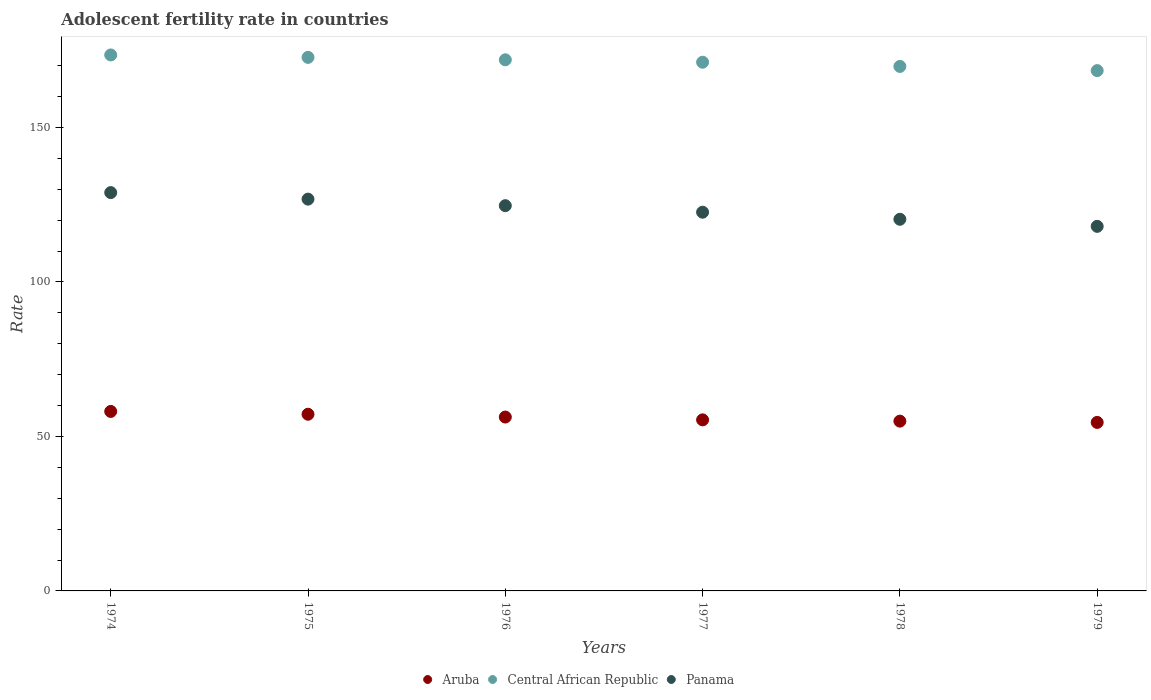What is the adolescent fertility rate in Central African Republic in 1974?
Your answer should be compact. 173.48. Across all years, what is the maximum adolescent fertility rate in Central African Republic?
Your answer should be compact. 173.48. Across all years, what is the minimum adolescent fertility rate in Aruba?
Offer a terse response. 54.54. In which year was the adolescent fertility rate in Central African Republic maximum?
Offer a very short reply. 1974. In which year was the adolescent fertility rate in Aruba minimum?
Give a very brief answer. 1979. What is the total adolescent fertility rate in Central African Republic in the graph?
Ensure brevity in your answer.  1027.37. What is the difference between the adolescent fertility rate in Aruba in 1974 and that in 1975?
Give a very brief answer. 0.91. What is the difference between the adolescent fertility rate in Aruba in 1977 and the adolescent fertility rate in Central African Republic in 1974?
Ensure brevity in your answer.  -118.11. What is the average adolescent fertility rate in Aruba per year?
Give a very brief answer. 56.07. In the year 1977, what is the difference between the adolescent fertility rate in Central African Republic and adolescent fertility rate in Panama?
Your response must be concise. 48.55. In how many years, is the adolescent fertility rate in Aruba greater than 60?
Offer a very short reply. 0. What is the ratio of the adolescent fertility rate in Aruba in 1976 to that in 1978?
Keep it short and to the point. 1.02. Is the difference between the adolescent fertility rate in Central African Republic in 1975 and 1977 greater than the difference between the adolescent fertility rate in Panama in 1975 and 1977?
Provide a succinct answer. No. What is the difference between the highest and the second highest adolescent fertility rate in Panama?
Provide a short and direct response. 2.12. What is the difference between the highest and the lowest adolescent fertility rate in Central African Republic?
Provide a succinct answer. 5.07. In how many years, is the adolescent fertility rate in Panama greater than the average adolescent fertility rate in Panama taken over all years?
Offer a very short reply. 3. Does the adolescent fertility rate in Panama monotonically increase over the years?
Give a very brief answer. No. How many dotlines are there?
Give a very brief answer. 3. How many years are there in the graph?
Provide a short and direct response. 6. What is the difference between two consecutive major ticks on the Y-axis?
Ensure brevity in your answer.  50. Does the graph contain any zero values?
Keep it short and to the point. No. Does the graph contain grids?
Your response must be concise. No. How many legend labels are there?
Your response must be concise. 3. What is the title of the graph?
Offer a terse response. Adolescent fertility rate in countries. Does "Denmark" appear as one of the legend labels in the graph?
Your answer should be very brief. No. What is the label or title of the Y-axis?
Your answer should be compact. Rate. What is the Rate in Aruba in 1974?
Offer a terse response. 58.1. What is the Rate in Central African Republic in 1974?
Give a very brief answer. 173.48. What is the Rate in Panama in 1974?
Provide a short and direct response. 128.93. What is the Rate in Aruba in 1975?
Offer a very short reply. 57.19. What is the Rate of Central African Republic in 1975?
Your answer should be very brief. 172.69. What is the Rate of Panama in 1975?
Offer a very short reply. 126.81. What is the Rate in Aruba in 1976?
Your response must be concise. 56.28. What is the Rate in Central African Republic in 1976?
Keep it short and to the point. 171.91. What is the Rate of Panama in 1976?
Offer a very short reply. 124.69. What is the Rate of Aruba in 1977?
Give a very brief answer. 55.37. What is the Rate in Central African Republic in 1977?
Give a very brief answer. 171.12. What is the Rate of Panama in 1977?
Make the answer very short. 122.58. What is the Rate of Aruba in 1978?
Your answer should be very brief. 54.95. What is the Rate of Central African Republic in 1978?
Ensure brevity in your answer.  169.77. What is the Rate of Panama in 1978?
Provide a succinct answer. 120.29. What is the Rate in Aruba in 1979?
Offer a terse response. 54.54. What is the Rate in Central African Republic in 1979?
Make the answer very short. 168.41. What is the Rate of Panama in 1979?
Offer a very short reply. 118. Across all years, what is the maximum Rate in Aruba?
Offer a terse response. 58.1. Across all years, what is the maximum Rate of Central African Republic?
Keep it short and to the point. 173.48. Across all years, what is the maximum Rate of Panama?
Provide a short and direct response. 128.93. Across all years, what is the minimum Rate of Aruba?
Provide a succinct answer. 54.54. Across all years, what is the minimum Rate of Central African Republic?
Your answer should be very brief. 168.41. Across all years, what is the minimum Rate of Panama?
Your response must be concise. 118. What is the total Rate in Aruba in the graph?
Offer a terse response. 336.42. What is the total Rate in Central African Republic in the graph?
Provide a succinct answer. 1027.37. What is the total Rate of Panama in the graph?
Your response must be concise. 741.3. What is the difference between the Rate in Aruba in 1974 and that in 1975?
Offer a terse response. 0.91. What is the difference between the Rate in Central African Republic in 1974 and that in 1975?
Offer a terse response. 0.79. What is the difference between the Rate of Panama in 1974 and that in 1975?
Provide a short and direct response. 2.12. What is the difference between the Rate in Aruba in 1974 and that in 1976?
Provide a short and direct response. 1.82. What is the difference between the Rate in Central African Republic in 1974 and that in 1976?
Make the answer very short. 1.57. What is the difference between the Rate of Panama in 1974 and that in 1976?
Offer a terse response. 4.23. What is the difference between the Rate of Aruba in 1974 and that in 1977?
Ensure brevity in your answer.  2.73. What is the difference between the Rate of Central African Republic in 1974 and that in 1977?
Keep it short and to the point. 2.36. What is the difference between the Rate in Panama in 1974 and that in 1977?
Make the answer very short. 6.35. What is the difference between the Rate of Aruba in 1974 and that in 1978?
Keep it short and to the point. 3.14. What is the difference between the Rate of Central African Republic in 1974 and that in 1978?
Keep it short and to the point. 3.71. What is the difference between the Rate in Panama in 1974 and that in 1978?
Offer a terse response. 8.64. What is the difference between the Rate of Aruba in 1974 and that in 1979?
Your answer should be compact. 3.56. What is the difference between the Rate in Central African Republic in 1974 and that in 1979?
Offer a terse response. 5.07. What is the difference between the Rate in Panama in 1974 and that in 1979?
Provide a succinct answer. 10.92. What is the difference between the Rate in Aruba in 1975 and that in 1976?
Your response must be concise. 0.91. What is the difference between the Rate in Central African Republic in 1975 and that in 1976?
Make the answer very short. 0.79. What is the difference between the Rate of Panama in 1975 and that in 1976?
Offer a very short reply. 2.12. What is the difference between the Rate in Aruba in 1975 and that in 1977?
Make the answer very short. 1.82. What is the difference between the Rate in Central African Republic in 1975 and that in 1977?
Give a very brief answer. 1.57. What is the difference between the Rate in Panama in 1975 and that in 1977?
Your answer should be compact. 4.23. What is the difference between the Rate of Aruba in 1975 and that in 1978?
Ensure brevity in your answer.  2.23. What is the difference between the Rate of Central African Republic in 1975 and that in 1978?
Offer a very short reply. 2.93. What is the difference between the Rate of Panama in 1975 and that in 1978?
Keep it short and to the point. 6.52. What is the difference between the Rate of Aruba in 1975 and that in 1979?
Offer a terse response. 2.65. What is the difference between the Rate of Central African Republic in 1975 and that in 1979?
Make the answer very short. 4.28. What is the difference between the Rate of Panama in 1975 and that in 1979?
Provide a short and direct response. 8.81. What is the difference between the Rate of Aruba in 1976 and that in 1977?
Your answer should be compact. 0.91. What is the difference between the Rate of Central African Republic in 1976 and that in 1977?
Make the answer very short. 0.79. What is the difference between the Rate of Panama in 1976 and that in 1977?
Keep it short and to the point. 2.12. What is the difference between the Rate in Aruba in 1976 and that in 1978?
Offer a very short reply. 1.32. What is the difference between the Rate of Central African Republic in 1976 and that in 1978?
Offer a very short reply. 2.14. What is the difference between the Rate in Panama in 1976 and that in 1978?
Provide a succinct answer. 4.4. What is the difference between the Rate in Aruba in 1976 and that in 1979?
Provide a succinct answer. 1.74. What is the difference between the Rate in Central African Republic in 1976 and that in 1979?
Offer a very short reply. 3.5. What is the difference between the Rate of Panama in 1976 and that in 1979?
Your answer should be compact. 6.69. What is the difference between the Rate in Aruba in 1977 and that in 1978?
Make the answer very short. 0.42. What is the difference between the Rate of Central African Republic in 1977 and that in 1978?
Your answer should be very brief. 1.36. What is the difference between the Rate in Panama in 1977 and that in 1978?
Make the answer very short. 2.29. What is the difference between the Rate of Aruba in 1977 and that in 1979?
Offer a very short reply. 0.83. What is the difference between the Rate in Central African Republic in 1977 and that in 1979?
Keep it short and to the point. 2.71. What is the difference between the Rate of Panama in 1977 and that in 1979?
Give a very brief answer. 4.58. What is the difference between the Rate in Aruba in 1978 and that in 1979?
Give a very brief answer. 0.42. What is the difference between the Rate in Central African Republic in 1978 and that in 1979?
Make the answer very short. 1.36. What is the difference between the Rate in Panama in 1978 and that in 1979?
Give a very brief answer. 2.29. What is the difference between the Rate of Aruba in 1974 and the Rate of Central African Republic in 1975?
Provide a succinct answer. -114.6. What is the difference between the Rate in Aruba in 1974 and the Rate in Panama in 1975?
Your answer should be very brief. -68.71. What is the difference between the Rate in Central African Republic in 1974 and the Rate in Panama in 1975?
Your answer should be compact. 46.67. What is the difference between the Rate in Aruba in 1974 and the Rate in Central African Republic in 1976?
Provide a succinct answer. -113.81. What is the difference between the Rate in Aruba in 1974 and the Rate in Panama in 1976?
Offer a very short reply. -66.6. What is the difference between the Rate in Central African Republic in 1974 and the Rate in Panama in 1976?
Provide a succinct answer. 48.78. What is the difference between the Rate of Aruba in 1974 and the Rate of Central African Republic in 1977?
Offer a very short reply. -113.03. What is the difference between the Rate of Aruba in 1974 and the Rate of Panama in 1977?
Your response must be concise. -64.48. What is the difference between the Rate of Central African Republic in 1974 and the Rate of Panama in 1977?
Your answer should be very brief. 50.9. What is the difference between the Rate of Aruba in 1974 and the Rate of Central African Republic in 1978?
Make the answer very short. -111.67. What is the difference between the Rate in Aruba in 1974 and the Rate in Panama in 1978?
Make the answer very short. -62.19. What is the difference between the Rate of Central African Republic in 1974 and the Rate of Panama in 1978?
Ensure brevity in your answer.  53.19. What is the difference between the Rate of Aruba in 1974 and the Rate of Central African Republic in 1979?
Your answer should be compact. -110.31. What is the difference between the Rate of Aruba in 1974 and the Rate of Panama in 1979?
Your response must be concise. -59.91. What is the difference between the Rate in Central African Republic in 1974 and the Rate in Panama in 1979?
Provide a short and direct response. 55.48. What is the difference between the Rate in Aruba in 1975 and the Rate in Central African Republic in 1976?
Give a very brief answer. -114.72. What is the difference between the Rate of Aruba in 1975 and the Rate of Panama in 1976?
Your response must be concise. -67.51. What is the difference between the Rate of Central African Republic in 1975 and the Rate of Panama in 1976?
Your answer should be very brief. 48. What is the difference between the Rate of Aruba in 1975 and the Rate of Central African Republic in 1977?
Keep it short and to the point. -113.93. What is the difference between the Rate in Aruba in 1975 and the Rate in Panama in 1977?
Your response must be concise. -65.39. What is the difference between the Rate in Central African Republic in 1975 and the Rate in Panama in 1977?
Your response must be concise. 50.12. What is the difference between the Rate of Aruba in 1975 and the Rate of Central African Republic in 1978?
Your answer should be compact. -112.58. What is the difference between the Rate in Aruba in 1975 and the Rate in Panama in 1978?
Offer a terse response. -63.1. What is the difference between the Rate in Central African Republic in 1975 and the Rate in Panama in 1978?
Keep it short and to the point. 52.4. What is the difference between the Rate of Aruba in 1975 and the Rate of Central African Republic in 1979?
Provide a short and direct response. -111.22. What is the difference between the Rate of Aruba in 1975 and the Rate of Panama in 1979?
Offer a very short reply. -60.81. What is the difference between the Rate of Central African Republic in 1975 and the Rate of Panama in 1979?
Keep it short and to the point. 54.69. What is the difference between the Rate in Aruba in 1976 and the Rate in Central African Republic in 1977?
Your answer should be compact. -114.84. What is the difference between the Rate of Aruba in 1976 and the Rate of Panama in 1977?
Your response must be concise. -66.3. What is the difference between the Rate of Central African Republic in 1976 and the Rate of Panama in 1977?
Make the answer very short. 49.33. What is the difference between the Rate of Aruba in 1976 and the Rate of Central African Republic in 1978?
Offer a terse response. -113.49. What is the difference between the Rate of Aruba in 1976 and the Rate of Panama in 1978?
Offer a terse response. -64.01. What is the difference between the Rate in Central African Republic in 1976 and the Rate in Panama in 1978?
Your answer should be compact. 51.62. What is the difference between the Rate in Aruba in 1976 and the Rate in Central African Republic in 1979?
Provide a short and direct response. -112.13. What is the difference between the Rate of Aruba in 1976 and the Rate of Panama in 1979?
Keep it short and to the point. -61.72. What is the difference between the Rate of Central African Republic in 1976 and the Rate of Panama in 1979?
Your response must be concise. 53.91. What is the difference between the Rate in Aruba in 1977 and the Rate in Central African Republic in 1978?
Your answer should be compact. -114.4. What is the difference between the Rate of Aruba in 1977 and the Rate of Panama in 1978?
Give a very brief answer. -64.92. What is the difference between the Rate of Central African Republic in 1977 and the Rate of Panama in 1978?
Give a very brief answer. 50.83. What is the difference between the Rate of Aruba in 1977 and the Rate of Central African Republic in 1979?
Your answer should be compact. -113.04. What is the difference between the Rate of Aruba in 1977 and the Rate of Panama in 1979?
Provide a succinct answer. -62.63. What is the difference between the Rate in Central African Republic in 1977 and the Rate in Panama in 1979?
Make the answer very short. 53.12. What is the difference between the Rate of Aruba in 1978 and the Rate of Central African Republic in 1979?
Your answer should be compact. -113.45. What is the difference between the Rate in Aruba in 1978 and the Rate in Panama in 1979?
Make the answer very short. -63.05. What is the difference between the Rate of Central African Republic in 1978 and the Rate of Panama in 1979?
Keep it short and to the point. 51.76. What is the average Rate in Aruba per year?
Offer a very short reply. 56.07. What is the average Rate of Central African Republic per year?
Offer a very short reply. 171.23. What is the average Rate in Panama per year?
Give a very brief answer. 123.55. In the year 1974, what is the difference between the Rate in Aruba and Rate in Central African Republic?
Make the answer very short. -115.38. In the year 1974, what is the difference between the Rate of Aruba and Rate of Panama?
Make the answer very short. -70.83. In the year 1974, what is the difference between the Rate in Central African Republic and Rate in Panama?
Provide a short and direct response. 44.55. In the year 1975, what is the difference between the Rate of Aruba and Rate of Central African Republic?
Your response must be concise. -115.51. In the year 1975, what is the difference between the Rate of Aruba and Rate of Panama?
Give a very brief answer. -69.62. In the year 1975, what is the difference between the Rate in Central African Republic and Rate in Panama?
Your answer should be compact. 45.88. In the year 1976, what is the difference between the Rate in Aruba and Rate in Central African Republic?
Offer a very short reply. -115.63. In the year 1976, what is the difference between the Rate of Aruba and Rate of Panama?
Your response must be concise. -68.41. In the year 1976, what is the difference between the Rate of Central African Republic and Rate of Panama?
Offer a terse response. 47.21. In the year 1977, what is the difference between the Rate of Aruba and Rate of Central African Republic?
Make the answer very short. -115.75. In the year 1977, what is the difference between the Rate of Aruba and Rate of Panama?
Make the answer very short. -67.21. In the year 1977, what is the difference between the Rate of Central African Republic and Rate of Panama?
Provide a short and direct response. 48.55. In the year 1978, what is the difference between the Rate in Aruba and Rate in Central African Republic?
Provide a short and direct response. -114.81. In the year 1978, what is the difference between the Rate of Aruba and Rate of Panama?
Offer a very short reply. -65.33. In the year 1978, what is the difference between the Rate of Central African Republic and Rate of Panama?
Ensure brevity in your answer.  49.48. In the year 1979, what is the difference between the Rate in Aruba and Rate in Central African Republic?
Provide a short and direct response. -113.87. In the year 1979, what is the difference between the Rate in Aruba and Rate in Panama?
Make the answer very short. -63.46. In the year 1979, what is the difference between the Rate of Central African Republic and Rate of Panama?
Your answer should be very brief. 50.41. What is the ratio of the Rate in Aruba in 1974 to that in 1975?
Your answer should be compact. 1.02. What is the ratio of the Rate in Panama in 1974 to that in 1975?
Provide a short and direct response. 1.02. What is the ratio of the Rate of Aruba in 1974 to that in 1976?
Your response must be concise. 1.03. What is the ratio of the Rate in Central African Republic in 1974 to that in 1976?
Offer a very short reply. 1.01. What is the ratio of the Rate in Panama in 1974 to that in 1976?
Provide a short and direct response. 1.03. What is the ratio of the Rate in Aruba in 1974 to that in 1977?
Provide a short and direct response. 1.05. What is the ratio of the Rate in Central African Republic in 1974 to that in 1977?
Make the answer very short. 1.01. What is the ratio of the Rate in Panama in 1974 to that in 1977?
Offer a very short reply. 1.05. What is the ratio of the Rate of Aruba in 1974 to that in 1978?
Offer a very short reply. 1.06. What is the ratio of the Rate in Central African Republic in 1974 to that in 1978?
Your answer should be compact. 1.02. What is the ratio of the Rate of Panama in 1974 to that in 1978?
Your answer should be compact. 1.07. What is the ratio of the Rate in Aruba in 1974 to that in 1979?
Offer a very short reply. 1.07. What is the ratio of the Rate of Central African Republic in 1974 to that in 1979?
Make the answer very short. 1.03. What is the ratio of the Rate in Panama in 1974 to that in 1979?
Give a very brief answer. 1.09. What is the ratio of the Rate of Aruba in 1975 to that in 1976?
Offer a very short reply. 1.02. What is the ratio of the Rate of Central African Republic in 1975 to that in 1976?
Provide a short and direct response. 1. What is the ratio of the Rate in Panama in 1975 to that in 1976?
Offer a terse response. 1.02. What is the ratio of the Rate in Aruba in 1975 to that in 1977?
Your answer should be compact. 1.03. What is the ratio of the Rate in Central African Republic in 1975 to that in 1977?
Your response must be concise. 1.01. What is the ratio of the Rate of Panama in 1975 to that in 1977?
Give a very brief answer. 1.03. What is the ratio of the Rate of Aruba in 1975 to that in 1978?
Provide a short and direct response. 1.04. What is the ratio of the Rate of Central African Republic in 1975 to that in 1978?
Your response must be concise. 1.02. What is the ratio of the Rate of Panama in 1975 to that in 1978?
Make the answer very short. 1.05. What is the ratio of the Rate in Aruba in 1975 to that in 1979?
Your answer should be very brief. 1.05. What is the ratio of the Rate in Central African Republic in 1975 to that in 1979?
Offer a very short reply. 1.03. What is the ratio of the Rate in Panama in 1975 to that in 1979?
Ensure brevity in your answer.  1.07. What is the ratio of the Rate in Aruba in 1976 to that in 1977?
Ensure brevity in your answer.  1.02. What is the ratio of the Rate in Panama in 1976 to that in 1977?
Your answer should be compact. 1.02. What is the ratio of the Rate of Aruba in 1976 to that in 1978?
Keep it short and to the point. 1.02. What is the ratio of the Rate in Central African Republic in 1976 to that in 1978?
Your answer should be very brief. 1.01. What is the ratio of the Rate in Panama in 1976 to that in 1978?
Ensure brevity in your answer.  1.04. What is the ratio of the Rate in Aruba in 1976 to that in 1979?
Your response must be concise. 1.03. What is the ratio of the Rate of Central African Republic in 1976 to that in 1979?
Offer a very short reply. 1.02. What is the ratio of the Rate of Panama in 1976 to that in 1979?
Keep it short and to the point. 1.06. What is the ratio of the Rate in Aruba in 1977 to that in 1978?
Offer a terse response. 1.01. What is the ratio of the Rate in Central African Republic in 1977 to that in 1978?
Your answer should be very brief. 1.01. What is the ratio of the Rate in Panama in 1977 to that in 1978?
Give a very brief answer. 1.02. What is the ratio of the Rate in Aruba in 1977 to that in 1979?
Ensure brevity in your answer.  1.02. What is the ratio of the Rate of Central African Republic in 1977 to that in 1979?
Keep it short and to the point. 1.02. What is the ratio of the Rate of Panama in 1977 to that in 1979?
Make the answer very short. 1.04. What is the ratio of the Rate of Aruba in 1978 to that in 1979?
Your answer should be compact. 1.01. What is the ratio of the Rate of Central African Republic in 1978 to that in 1979?
Give a very brief answer. 1.01. What is the ratio of the Rate of Panama in 1978 to that in 1979?
Provide a short and direct response. 1.02. What is the difference between the highest and the second highest Rate of Aruba?
Give a very brief answer. 0.91. What is the difference between the highest and the second highest Rate of Central African Republic?
Your answer should be compact. 0.79. What is the difference between the highest and the second highest Rate in Panama?
Offer a very short reply. 2.12. What is the difference between the highest and the lowest Rate of Aruba?
Make the answer very short. 3.56. What is the difference between the highest and the lowest Rate in Central African Republic?
Your response must be concise. 5.07. What is the difference between the highest and the lowest Rate of Panama?
Provide a short and direct response. 10.92. 